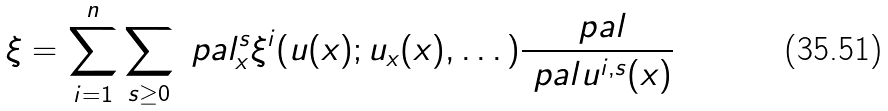<formula> <loc_0><loc_0><loc_500><loc_500>\xi = \sum _ { i = 1 } ^ { n } \sum _ { s \geq 0 } \ p a l _ { x } ^ { s } \xi ^ { i } ( u ( x ) ; u _ { x } ( x ) , \dots ) \frac { \ p a l } { \ p a l u ^ { i , s } ( x ) }</formula> 